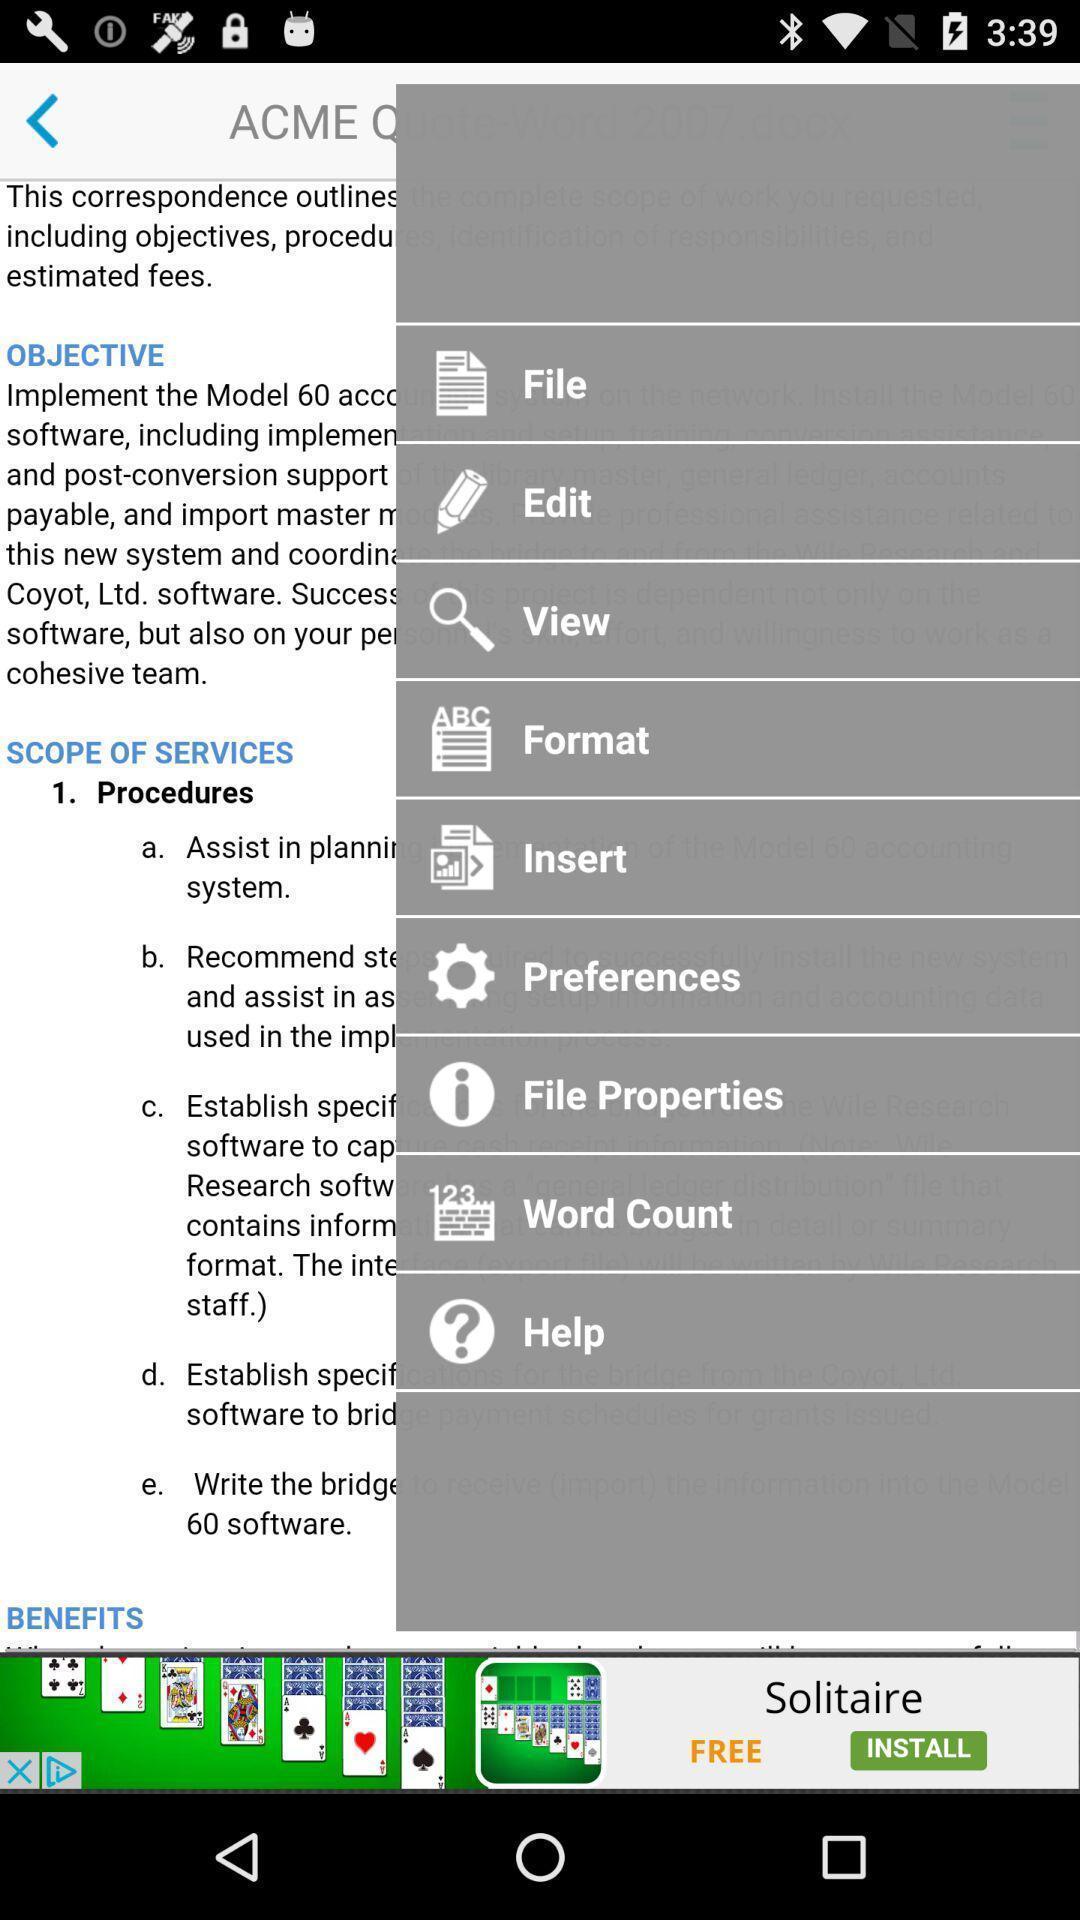Please provide a description for this image. Screen showing menu options. 